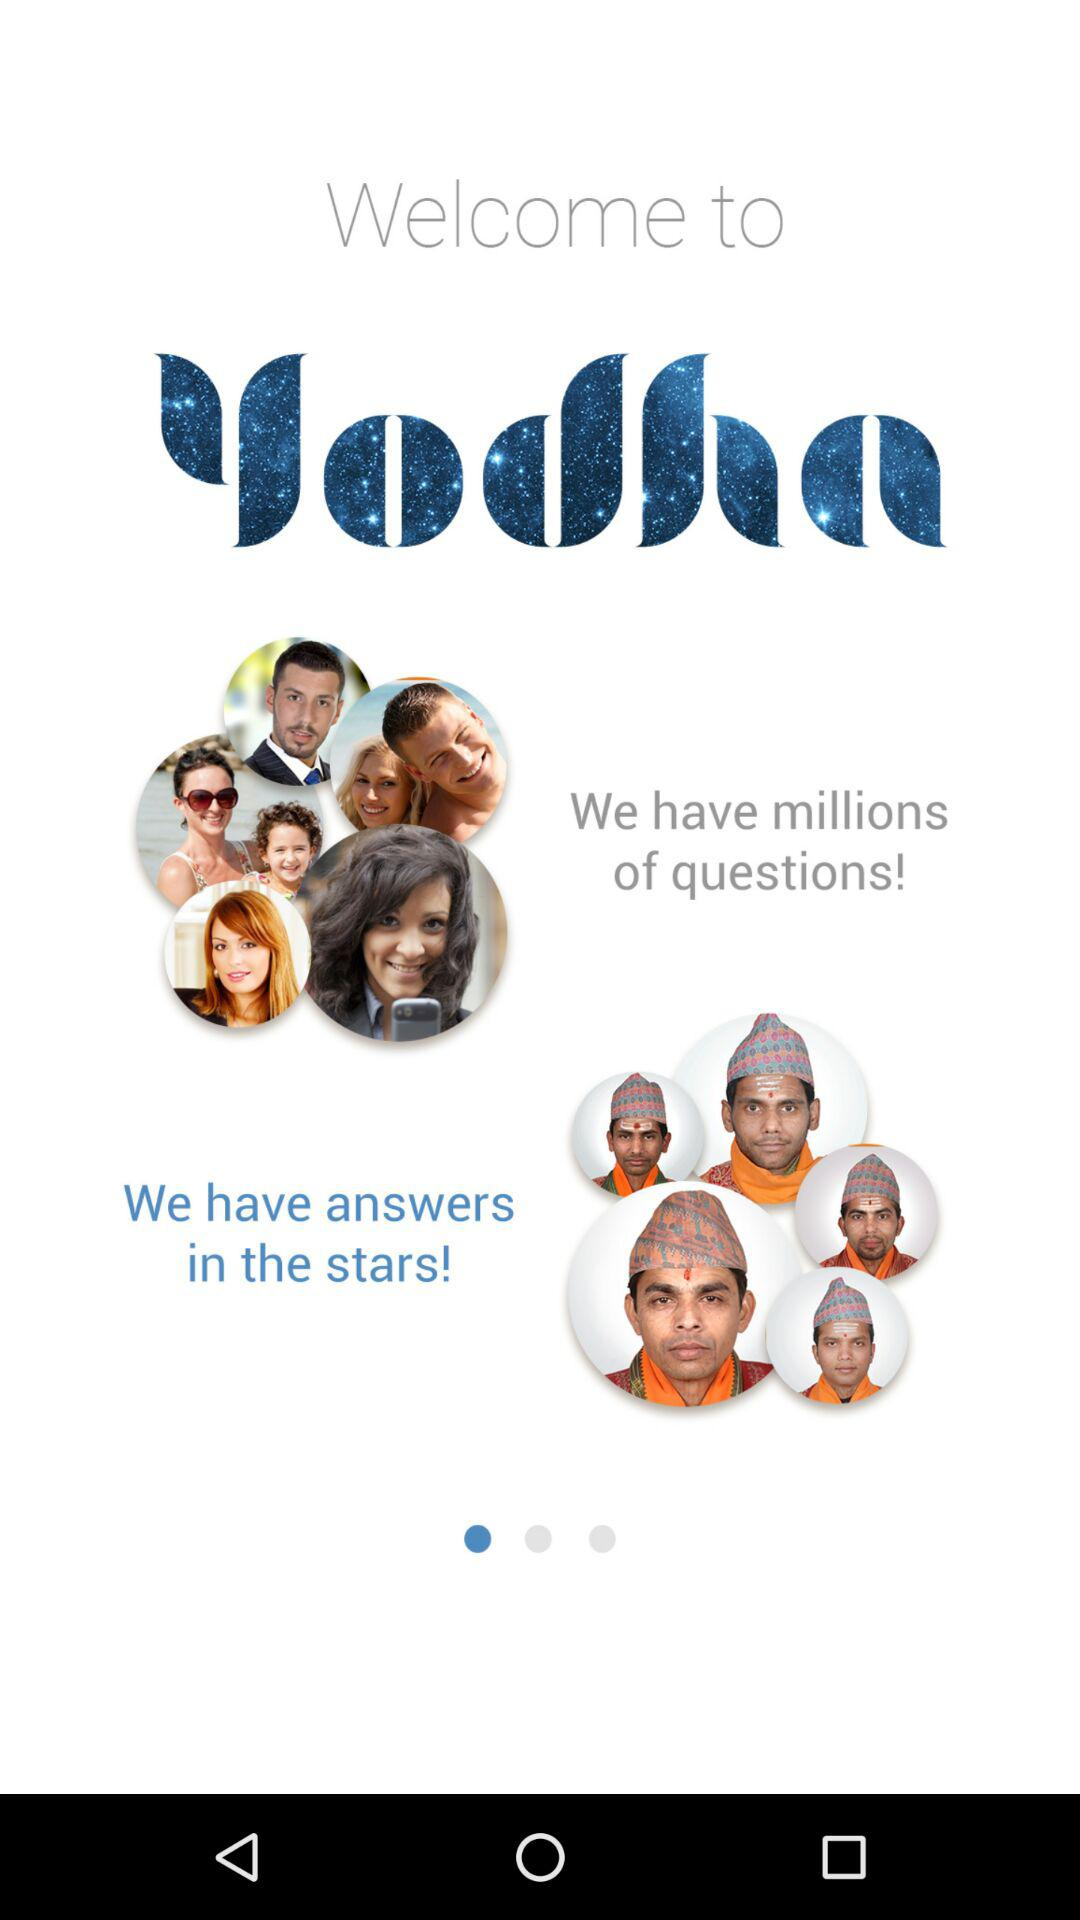What is the name of the application? The name of the application is "yodha". 